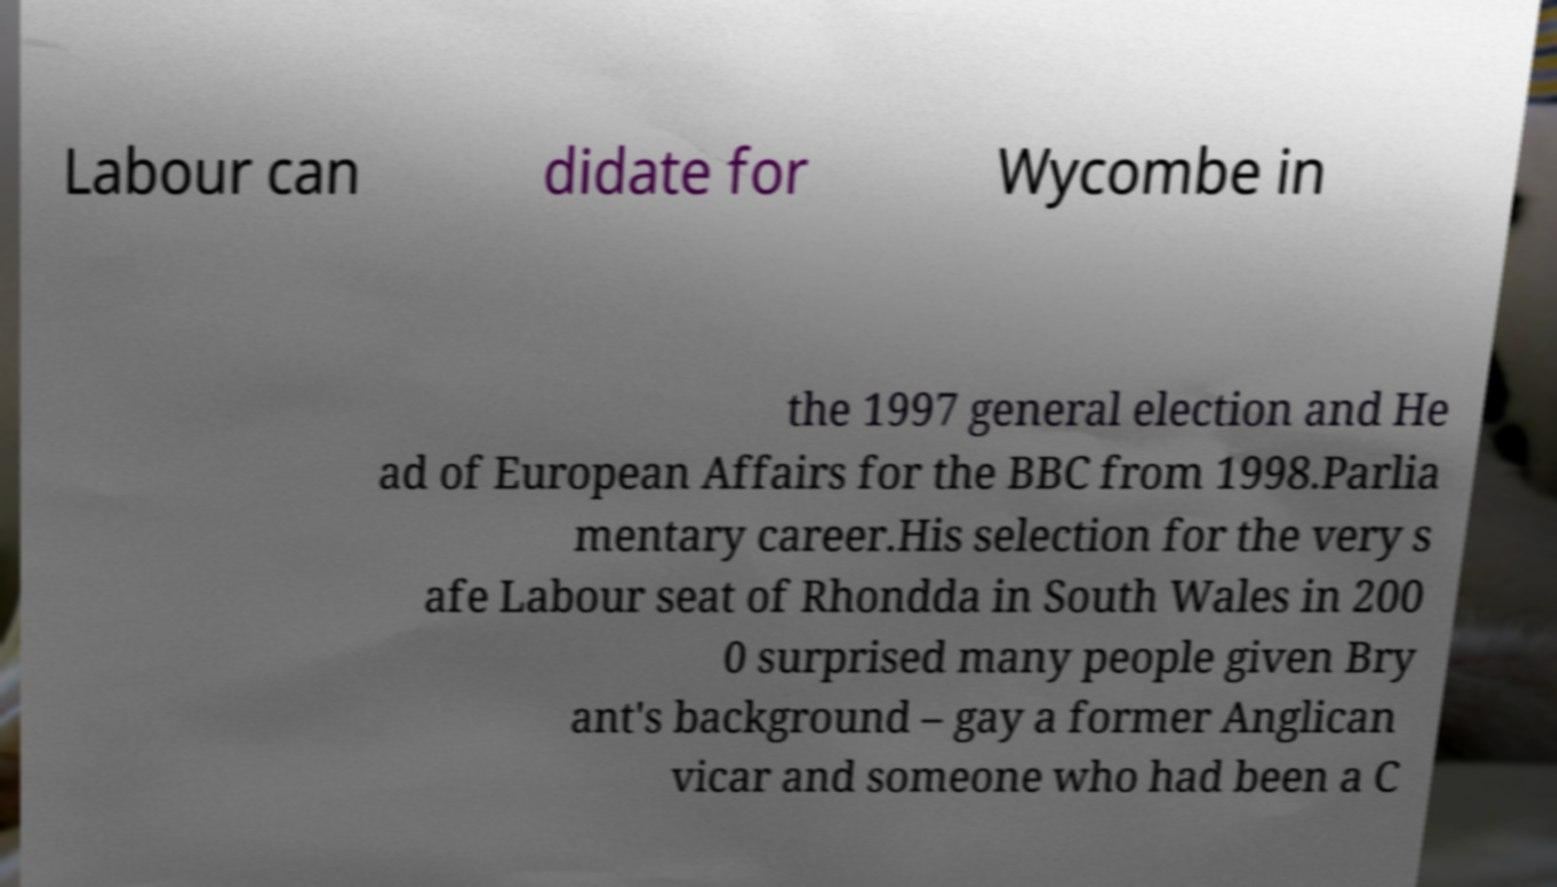For documentation purposes, I need the text within this image transcribed. Could you provide that? Labour can didate for Wycombe in the 1997 general election and He ad of European Affairs for the BBC from 1998.Parlia mentary career.His selection for the very s afe Labour seat of Rhondda in South Wales in 200 0 surprised many people given Bry ant's background – gay a former Anglican vicar and someone who had been a C 